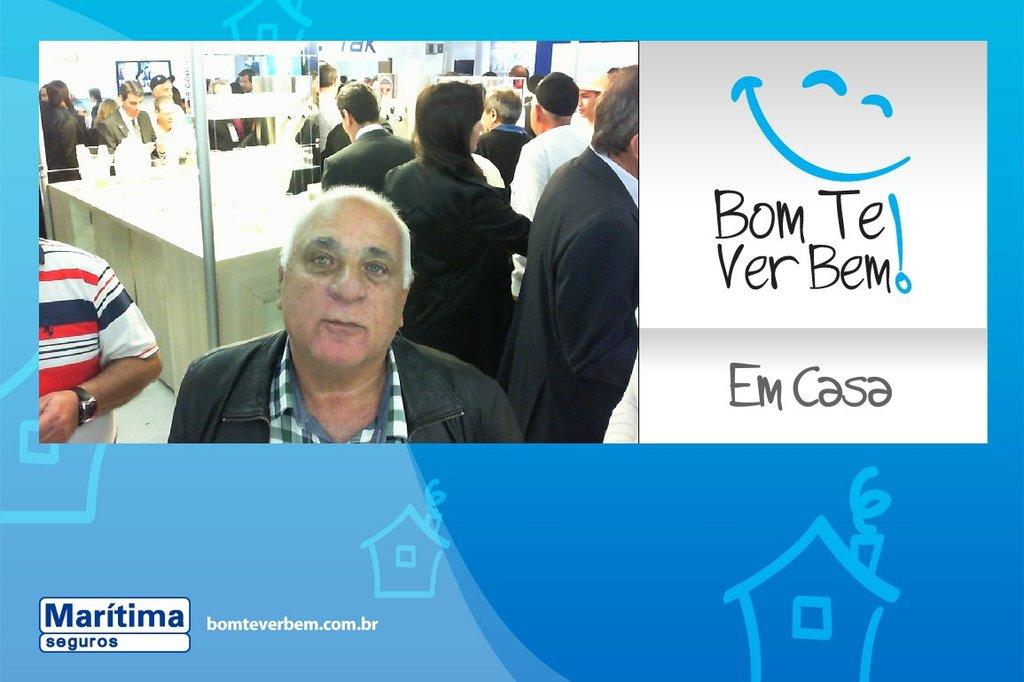Is the website ".com" or ".br"?
Your response must be concise. Both. 